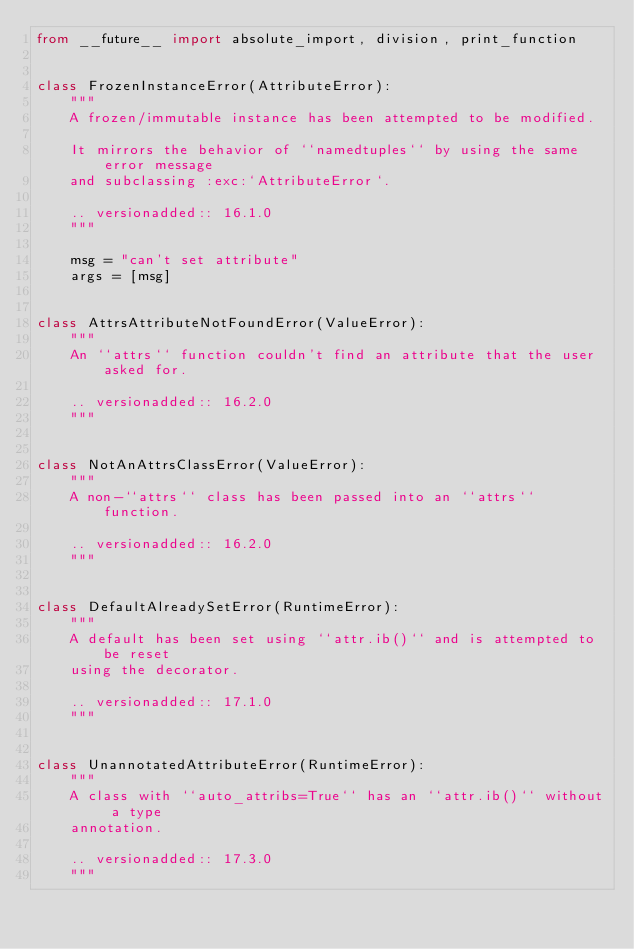<code> <loc_0><loc_0><loc_500><loc_500><_Python_>from __future__ import absolute_import, division, print_function


class FrozenInstanceError(AttributeError):
    """
    A frozen/immutable instance has been attempted to be modified.

    It mirrors the behavior of ``namedtuples`` by using the same error message
    and subclassing :exc:`AttributeError`.

    .. versionadded:: 16.1.0
    """

    msg = "can't set attribute"
    args = [msg]


class AttrsAttributeNotFoundError(ValueError):
    """
    An ``attrs`` function couldn't find an attribute that the user asked for.

    .. versionadded:: 16.2.0
    """


class NotAnAttrsClassError(ValueError):
    """
    A non-``attrs`` class has been passed into an ``attrs`` function.

    .. versionadded:: 16.2.0
    """


class DefaultAlreadySetError(RuntimeError):
    """
    A default has been set using ``attr.ib()`` and is attempted to be reset
    using the decorator.

    .. versionadded:: 17.1.0
    """


class UnannotatedAttributeError(RuntimeError):
    """
    A class with ``auto_attribs=True`` has an ``attr.ib()`` without a type
    annotation.

    .. versionadded:: 17.3.0
    """
</code> 